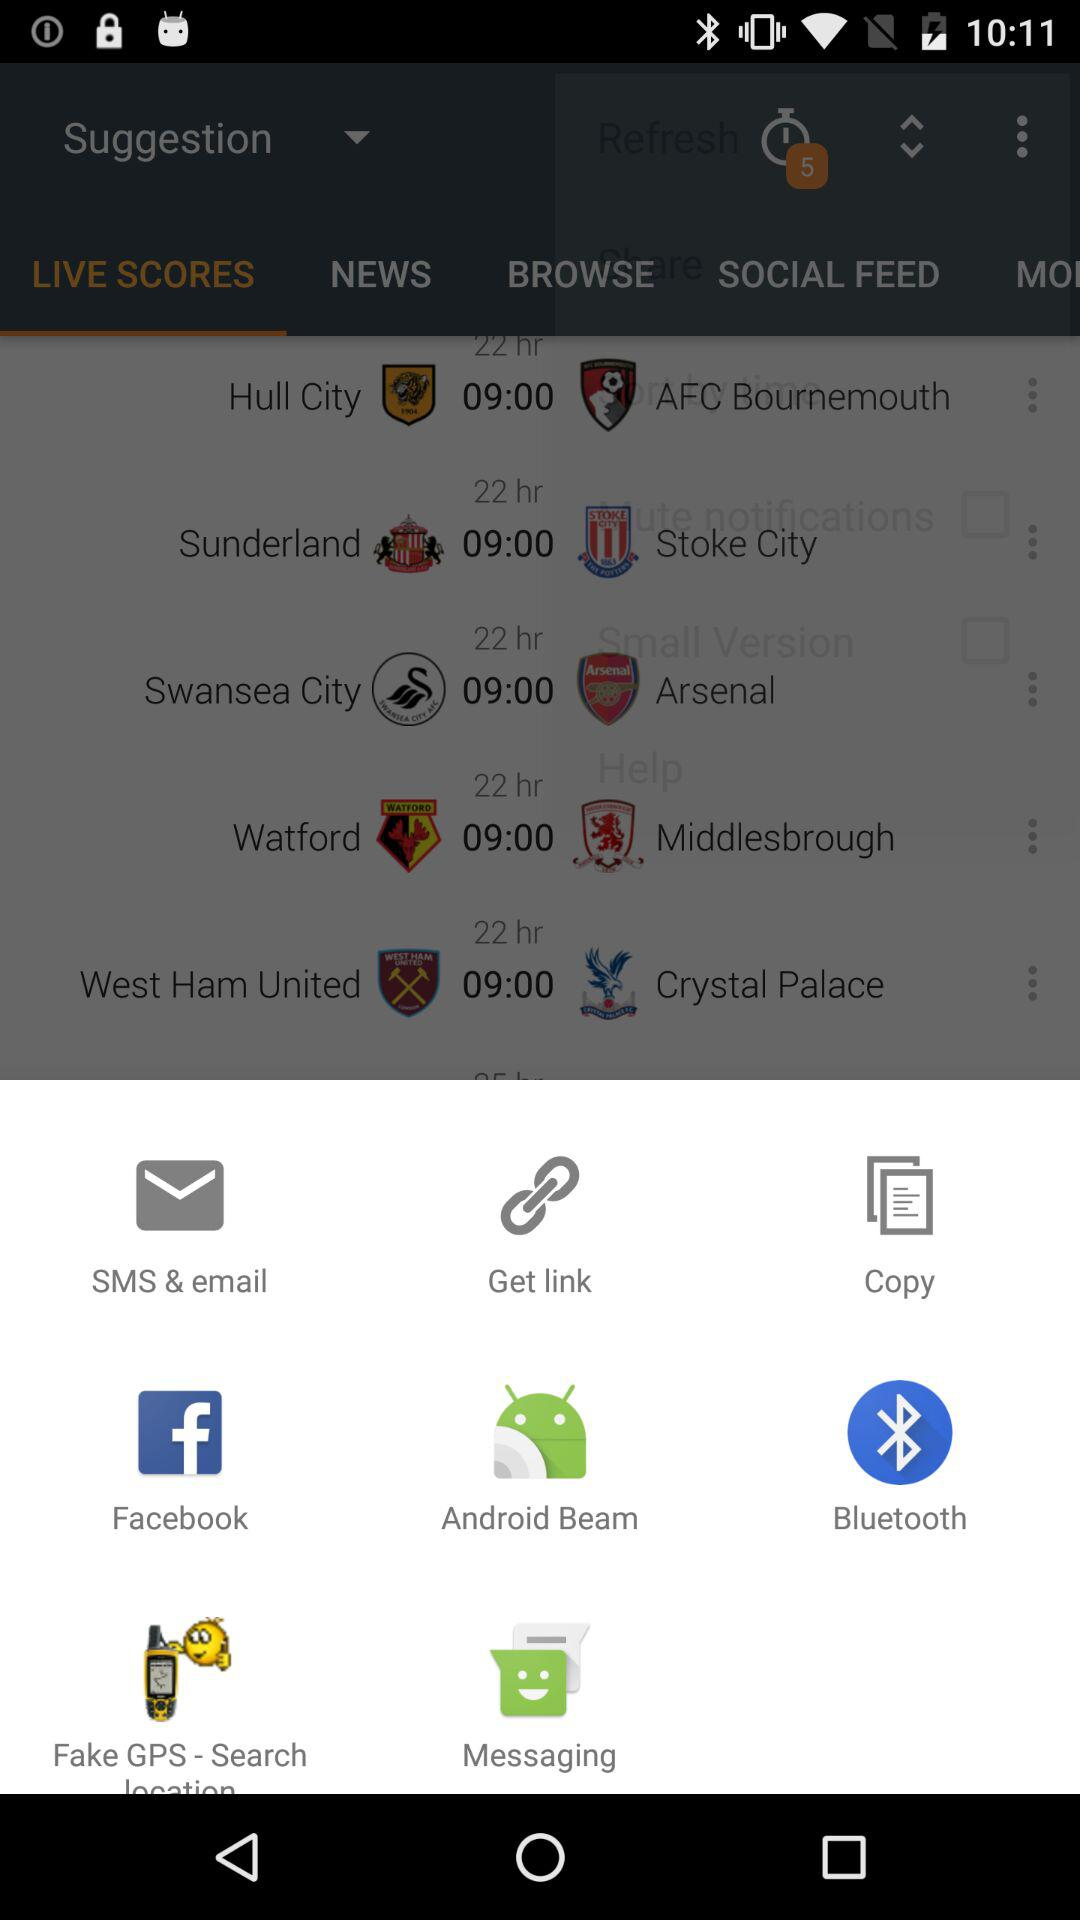How many unread notifications are shown? There are 5 unread notifications shown. 